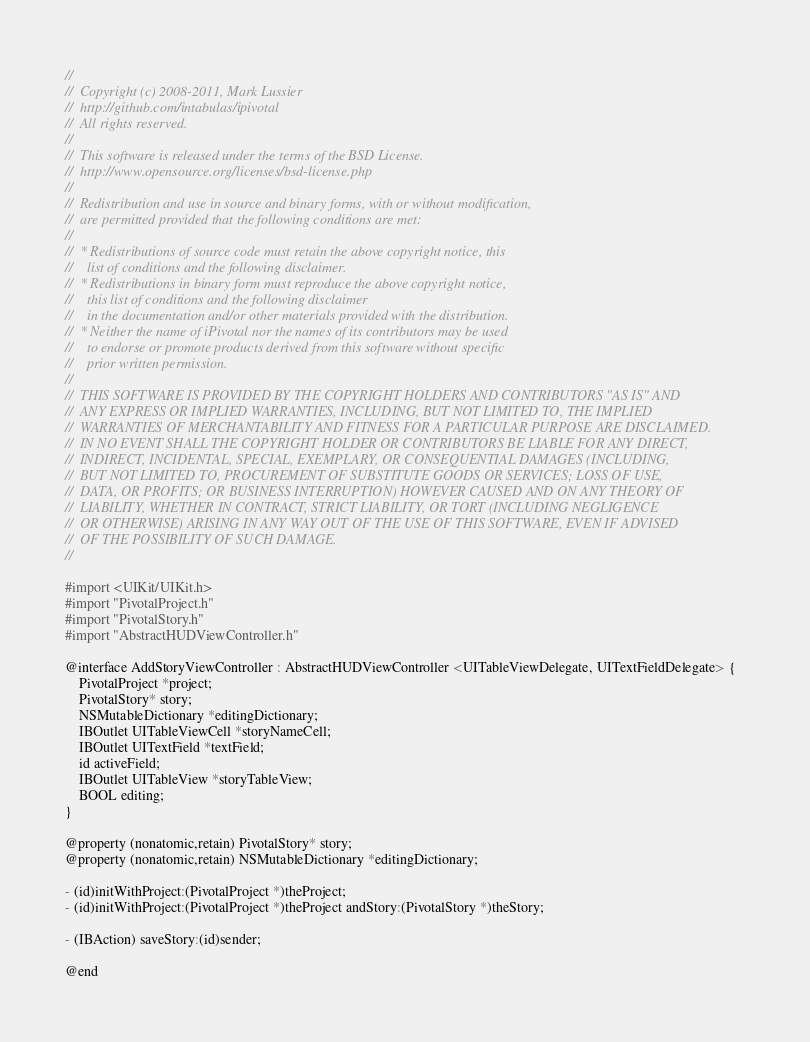Convert code to text. <code><loc_0><loc_0><loc_500><loc_500><_C_>//
//	Copyright (c) 2008-2011, Mark Lussier
//	http://github.com/intabulas/ipivotal
//	All rights reserved.
//
//	This software is released under the terms of the BSD License.
//	http://www.opensource.org/licenses/bsd-license.php
//
//	Redistribution and use in source and binary forms, with or without modification,
//	are permitted provided that the following conditions are met:
//
//	* Redistributions of source code must retain the above copyright notice, this
//	  list of conditions and the following disclaimer.
//	* Redistributions in binary form must reproduce the above copyright notice,
//	  this list of conditions and the following disclaimer
//	  in the documentation and/or other materials provided with the distribution.
//	* Neither the name of iPivotal nor the names of its contributors may be used
//	  to endorse or promote products derived from this software without specific
//	  prior written permission.
//
//	THIS SOFTWARE IS PROVIDED BY THE COPYRIGHT HOLDERS AND CONTRIBUTORS "AS IS" AND
//	ANY EXPRESS OR IMPLIED WARRANTIES, INCLUDING, BUT NOT LIMITED TO, THE IMPLIED
//	WARRANTIES OF MERCHANTABILITY AND FITNESS FOR A PARTICULAR PURPOSE ARE DISCLAIMED.
//	IN NO EVENT SHALL THE COPYRIGHT HOLDER OR CONTRIBUTORS BE LIABLE FOR ANY DIRECT,
//	INDIRECT, INCIDENTAL, SPECIAL, EXEMPLARY, OR CONSEQUENTIAL DAMAGES (INCLUDING,
//	BUT NOT LIMITED TO, PROCUREMENT OF SUBSTITUTE GOODS OR SERVICES; LOSS OF USE,
//	DATA, OR PROFITS; OR BUSINESS INTERRUPTION) HOWEVER CAUSED AND ON ANY THEORY OF
//	LIABILITY, WHETHER IN CONTRACT, STRICT LIABILITY, OR TORT (INCLUDING NEGLIGENCE
//	OR OTHERWISE) ARISING IN ANY WAY OUT OF THE USE OF THIS SOFTWARE, EVEN IF ADVISED
//	OF THE POSSIBILITY OF SUCH DAMAGE.
//

#import <UIKit/UIKit.h>
#import "PivotalProject.h"
#import "PivotalStory.h"
#import "AbstractHUDViewController.h"

@interface AddStoryViewController : AbstractHUDViewController <UITableViewDelegate, UITextFieldDelegate> {
    PivotalProject *project;
    PivotalStory* story;
    NSMutableDictionary *editingDictionary;
    IBOutlet UITableViewCell *storyNameCell;
    IBOutlet UITextField *textField;
    id activeField;
    IBOutlet UITableView *storyTableView;       
    BOOL editing;
}

@property (nonatomic,retain) PivotalStory* story;
@property (nonatomic,retain) NSMutableDictionary *editingDictionary;

- (id)initWithProject:(PivotalProject *)theProject;
- (id)initWithProject:(PivotalProject *)theProject andStory:(PivotalStory *)theStory;

- (IBAction) saveStory:(id)sender;

@end
</code> 